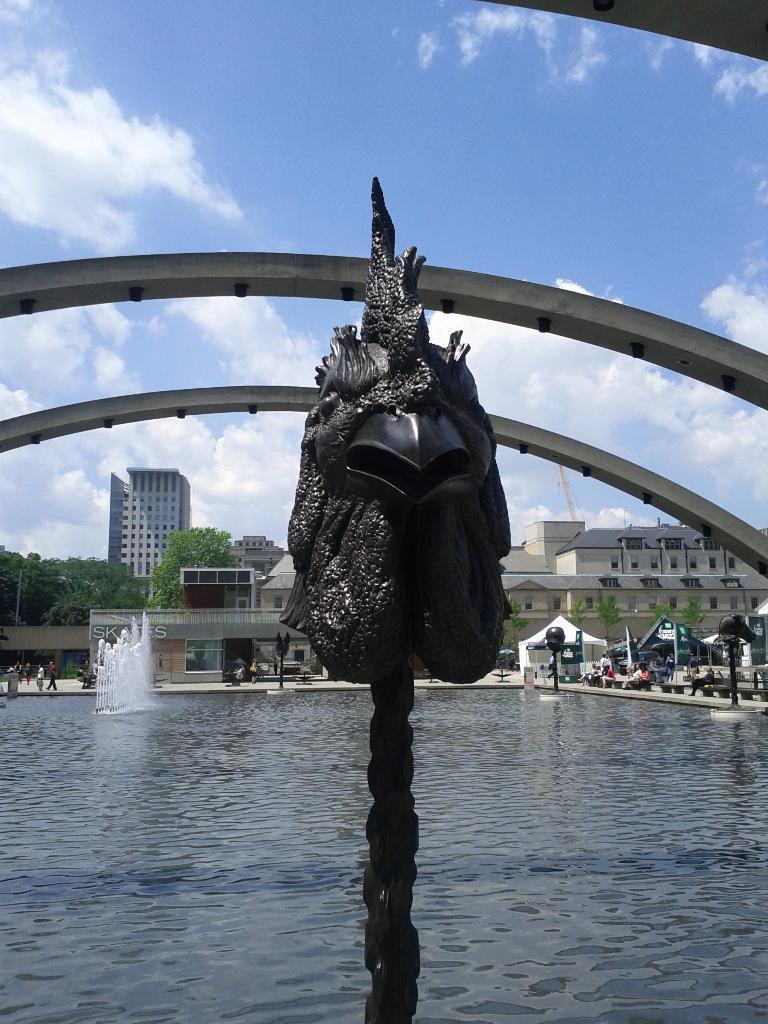In one or two sentences, can you explain what this image depicts? In this image we can see a fountain. At the bottom there is water and we can see an arch. In the background there are buildings, tents, trees and sky. 